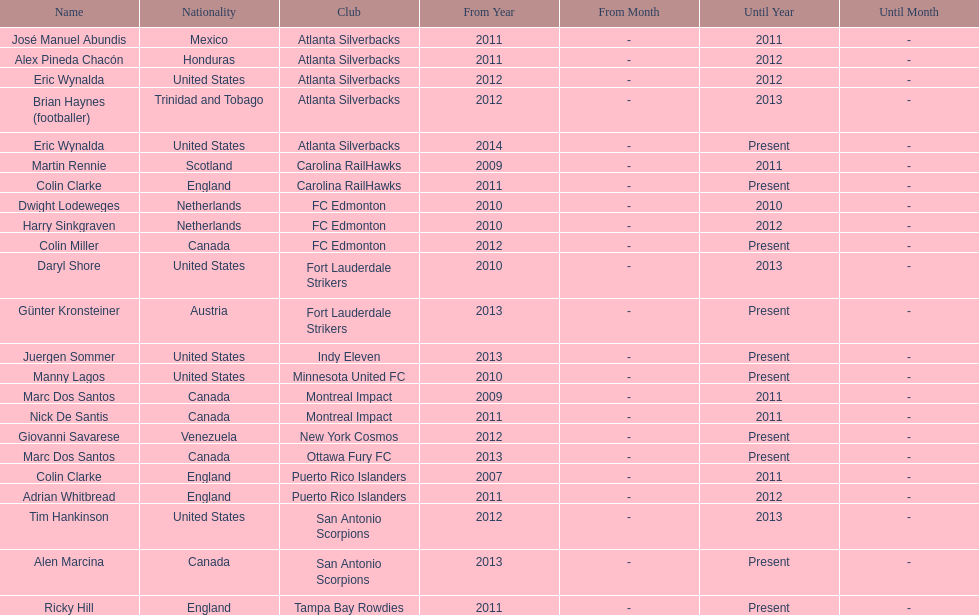Marc dos santos started as coach the same year as what other coach? Martin Rennie. 